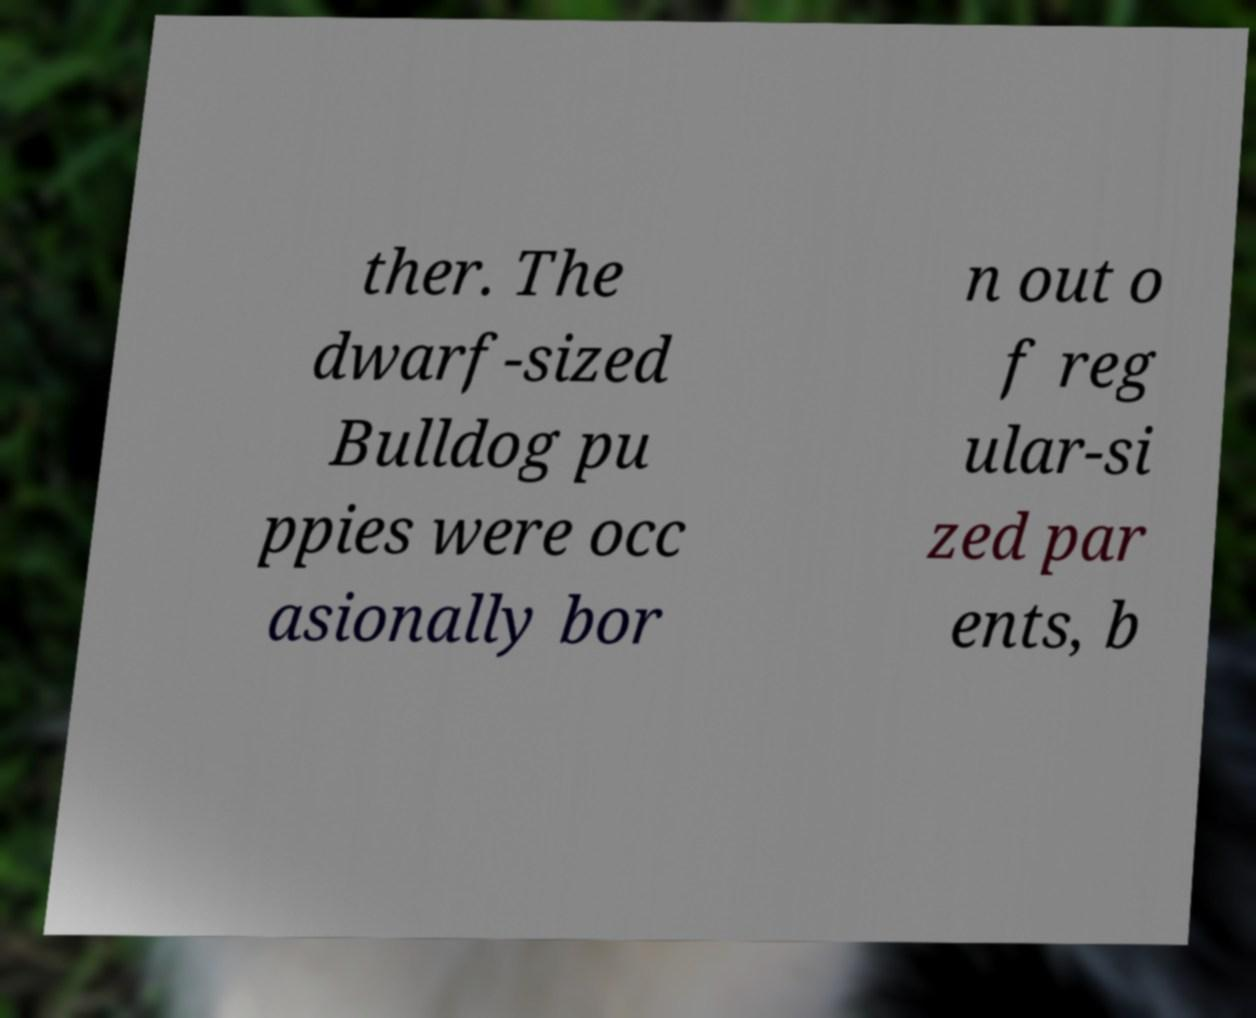Can you accurately transcribe the text from the provided image for me? ther. The dwarf-sized Bulldog pu ppies were occ asionally bor n out o f reg ular-si zed par ents, b 